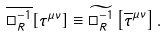<formula> <loc_0><loc_0><loc_500><loc_500>\overline { \Box _ { R } ^ { - 1 } } [ \tau ^ { \mu \nu } ] \equiv \widetilde { \Box _ { R } ^ { - 1 } } \left [ \overline { \tau } ^ { \mu \nu } \right ] .</formula> 